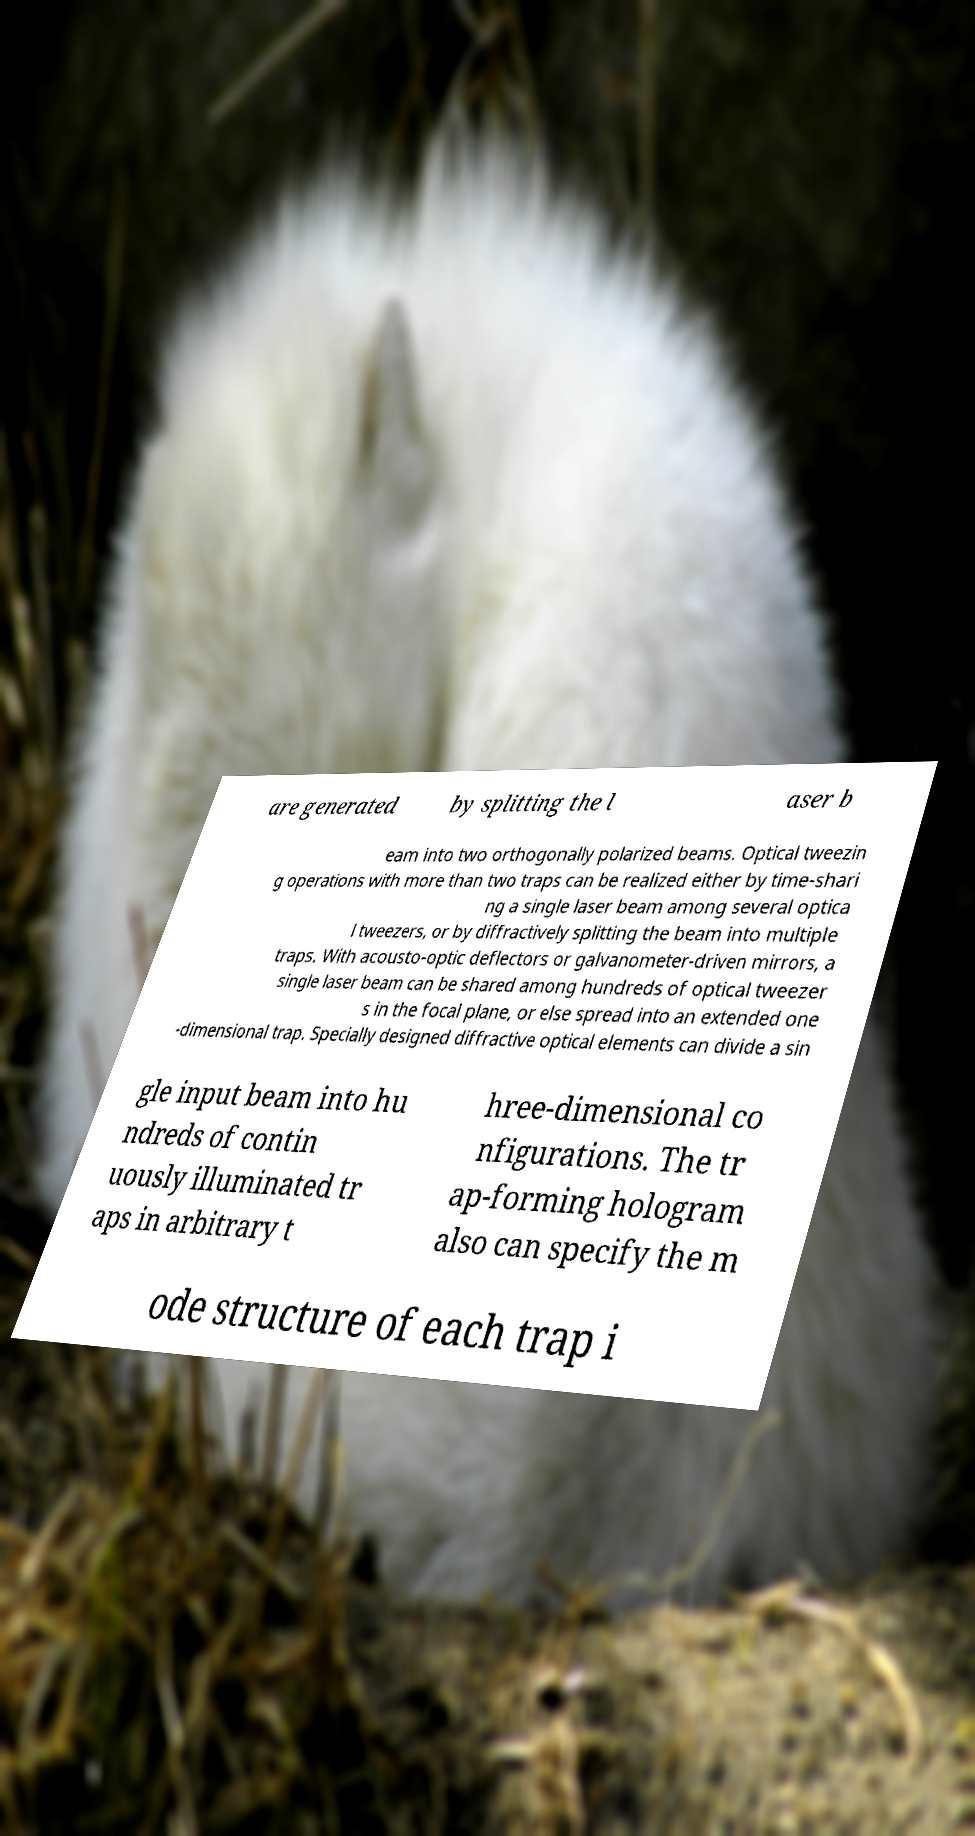Please read and relay the text visible in this image. What does it say? are generated by splitting the l aser b eam into two orthogonally polarized beams. Optical tweezin g operations with more than two traps can be realized either by time-shari ng a single laser beam among several optica l tweezers, or by diffractively splitting the beam into multiple traps. With acousto-optic deflectors or galvanometer-driven mirrors, a single laser beam can be shared among hundreds of optical tweezer s in the focal plane, or else spread into an extended one -dimensional trap. Specially designed diffractive optical elements can divide a sin gle input beam into hu ndreds of contin uously illuminated tr aps in arbitrary t hree-dimensional co nfigurations. The tr ap-forming hologram also can specify the m ode structure of each trap i 